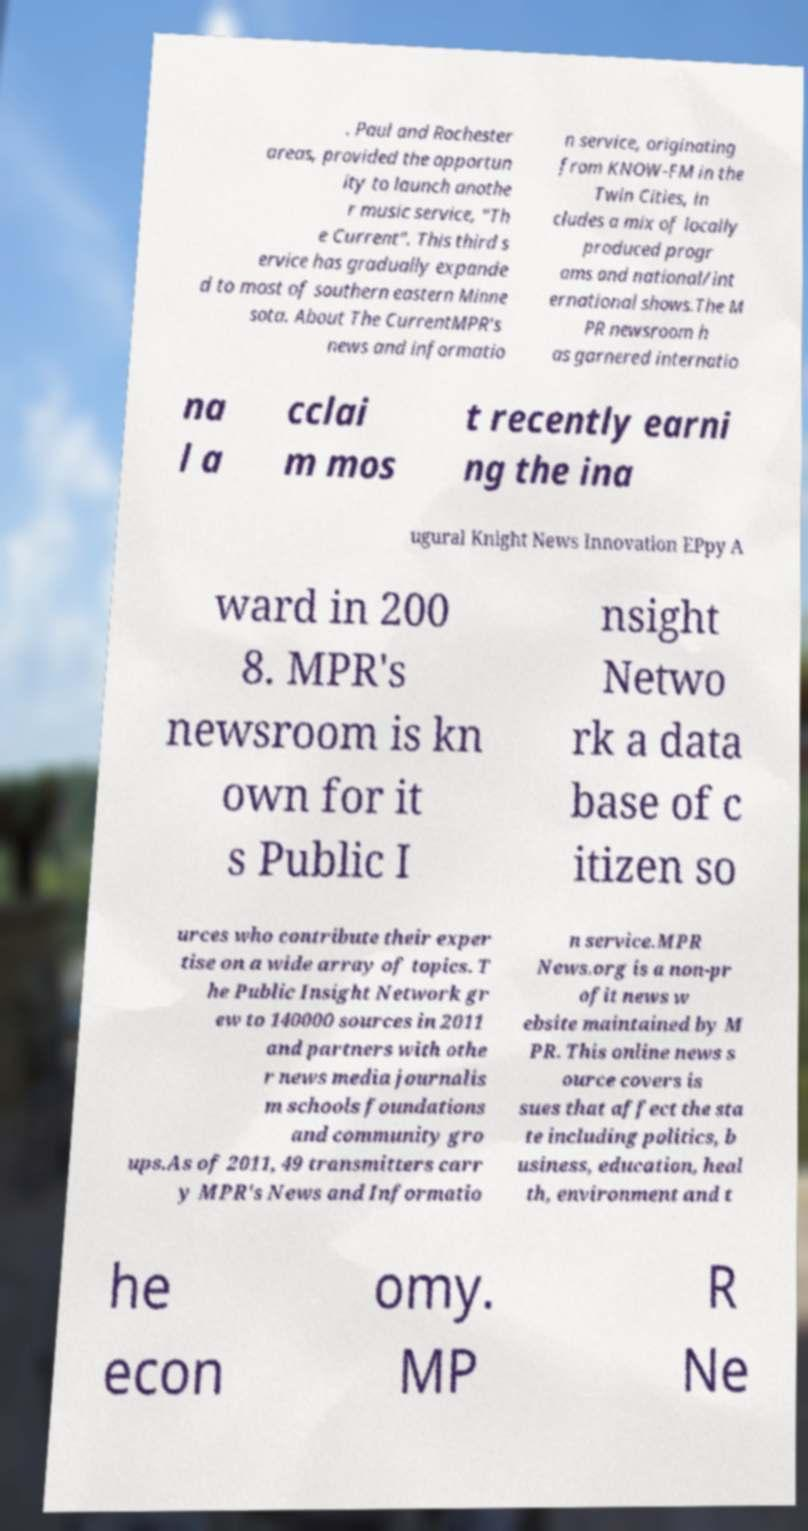I need the written content from this picture converted into text. Can you do that? . Paul and Rochester areas, provided the opportun ity to launch anothe r music service, "Th e Current". This third s ervice has gradually expande d to most of southern eastern Minne sota. About The CurrentMPR's news and informatio n service, originating from KNOW-FM in the Twin Cities, in cludes a mix of locally produced progr ams and national/int ernational shows.The M PR newsroom h as garnered internatio na l a cclai m mos t recently earni ng the ina ugural Knight News Innovation EPpy A ward in 200 8. MPR's newsroom is kn own for it s Public I nsight Netwo rk a data base of c itizen so urces who contribute their exper tise on a wide array of topics. T he Public Insight Network gr ew to 140000 sources in 2011 and partners with othe r news media journalis m schools foundations and community gro ups.As of 2011, 49 transmitters carr y MPR's News and Informatio n service.MPR News.org is a non-pr ofit news w ebsite maintained by M PR. This online news s ource covers is sues that affect the sta te including politics, b usiness, education, heal th, environment and t he econ omy. MP R Ne 